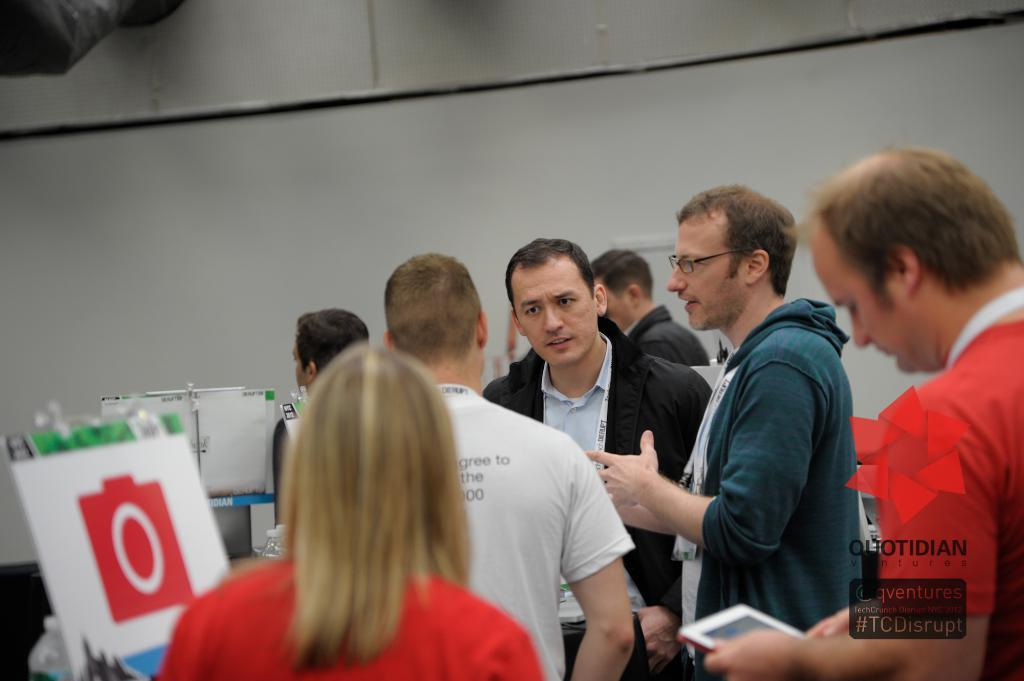How many people can be seen in the image? There are many persons in the image. What else is present in the image besides people? There are boats and boards in the image. What can be seen in the background of the image? There is a wall in the background of the image. Are there any slaves depicted in the image? There is no mention or indication of slaves in the image. What type of scarf is being worn by the persons in the image? There is no scarf visible in the image. 